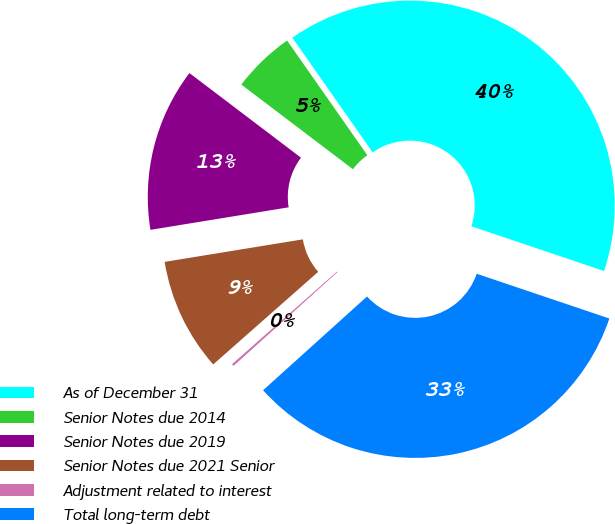Convert chart. <chart><loc_0><loc_0><loc_500><loc_500><pie_chart><fcel>As of December 31<fcel>Senior Notes due 2014<fcel>Senior Notes due 2019<fcel>Senior Notes due 2021 Senior<fcel>Adjustment related to interest<fcel>Total long-term debt<nl><fcel>39.9%<fcel>4.95%<fcel>12.9%<fcel>8.93%<fcel>0.18%<fcel>33.14%<nl></chart> 